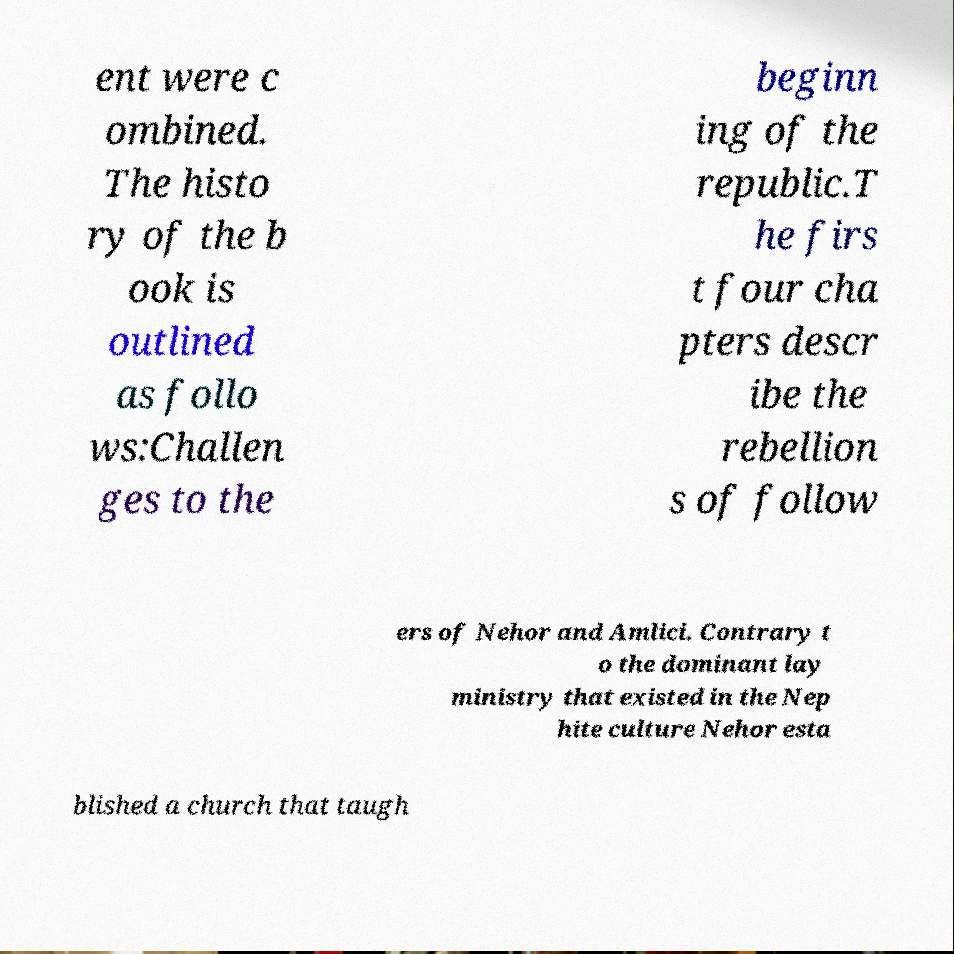Could you extract and type out the text from this image? ent were c ombined. The histo ry of the b ook is outlined as follo ws:Challen ges to the beginn ing of the republic.T he firs t four cha pters descr ibe the rebellion s of follow ers of Nehor and Amlici. Contrary t o the dominant lay ministry that existed in the Nep hite culture Nehor esta blished a church that taugh 